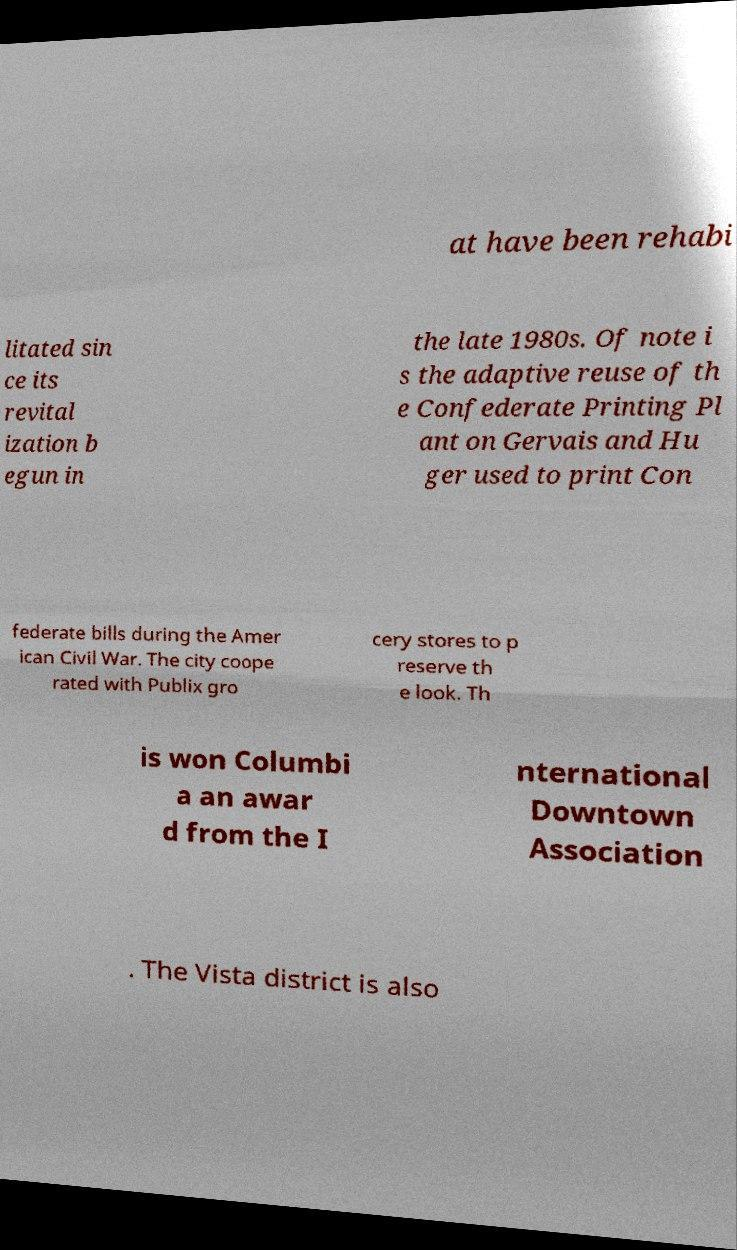Could you extract and type out the text from this image? at have been rehabi litated sin ce its revital ization b egun in the late 1980s. Of note i s the adaptive reuse of th e Confederate Printing Pl ant on Gervais and Hu ger used to print Con federate bills during the Amer ican Civil War. The city coope rated with Publix gro cery stores to p reserve th e look. Th is won Columbi a an awar d from the I nternational Downtown Association . The Vista district is also 